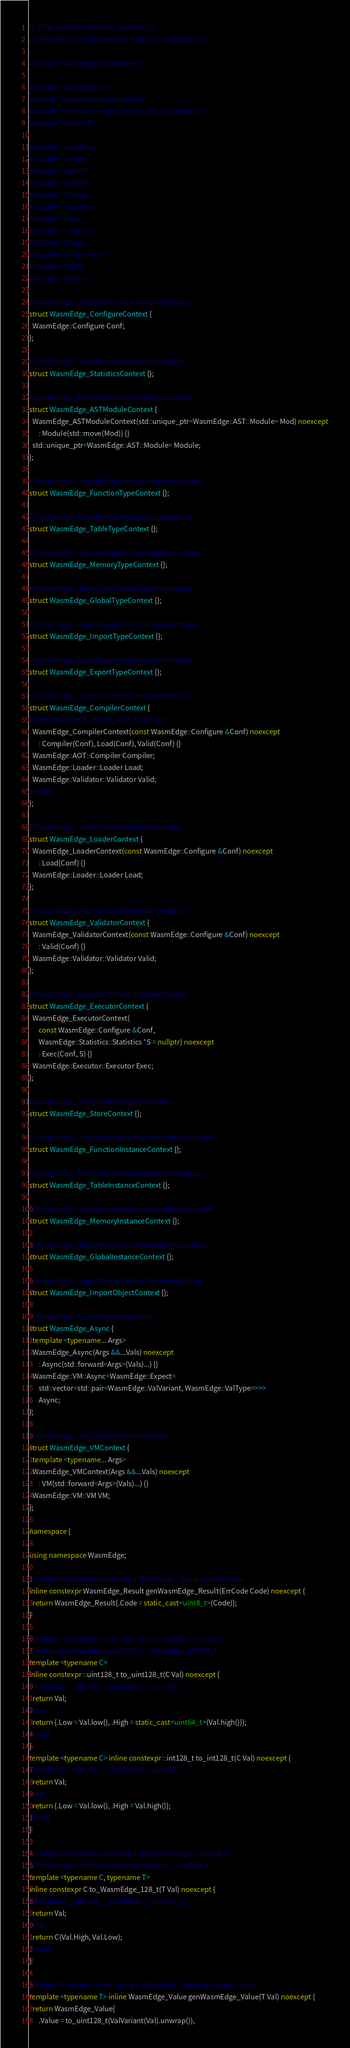Convert code to text. <code><loc_0><loc_0><loc_500><loc_500><_C++_>// SPDX-License-Identifier: Apache-2.0
// SPDX-FileCopyrightText: 2019-2022 Second State INC

#include "wasmedge/wasmedge.h"

#include "aot/compiler.h"
#include "host/wasi/wasimodule.h"
#include "host/wasmedge_process/processmodule.h"
#include "vm/vm.h"

#include <algorithm>
#include <chrono>
#include <cstdint>
#include <cstdlib>
#include <cstring>
#include <functional>
#include <map>
#include <memory>
#include <string>
#include <string_view>
#include <utility>
#include <vector>

// WasmEdge_ConfigureContext implementation.
struct WasmEdge_ConfigureContext {
  WasmEdge::Configure Conf;
};

// WasmEdge_StatisticsContext implementation.
struct WasmEdge_StatisticsContext {};

// WasmEdge_ASTModuleContext implementation.
struct WasmEdge_ASTModuleContext {
  WasmEdge_ASTModuleContext(std::unique_ptr<WasmEdge::AST::Module> Mod) noexcept
      : Module(std::move(Mod)) {}
  std::unique_ptr<WasmEdge::AST::Module> Module;
};

// WasmEdge_FunctionTypeContext implementation.
struct WasmEdge_FunctionTypeContext {};

// WasmEdge_TableTypeContext implementation.
struct WasmEdge_TableTypeContext {};

// WasmEdge_MemoryTypeContext implementation.
struct WasmEdge_MemoryTypeContext {};

// WasmEdge_GlobalTypeContext implementation.
struct WasmEdge_GlobalTypeContext {};

// WasmEdge_ImportTypeContext implementation.
struct WasmEdge_ImportTypeContext {};

// WasmEdge_ExportTypeContext implementation.
struct WasmEdge_ExportTypeContext {};

// WasmEdge_CompilerContext implementation.
struct WasmEdge_CompilerContext {
#ifdef WASMEDGE_BUILD_AOT_RUNTIME
  WasmEdge_CompilerContext(const WasmEdge::Configure &Conf) noexcept
      : Compiler(Conf), Load(Conf), Valid(Conf) {}
  WasmEdge::AOT::Compiler Compiler;
  WasmEdge::Loader::Loader Load;
  WasmEdge::Validator::Validator Valid;
#endif
};

// WasmEdge_LoaderContext implementation.
struct WasmEdge_LoaderContext {
  WasmEdge_LoaderContext(const WasmEdge::Configure &Conf) noexcept
      : Load(Conf) {}
  WasmEdge::Loader::Loader Load;
};

// WasmEdge_ValidatorContext implementation.
struct WasmEdge_ValidatorContext {
  WasmEdge_ValidatorContext(const WasmEdge::Configure &Conf) noexcept
      : Valid(Conf) {}
  WasmEdge::Validator::Validator Valid;
};

// WasmEdge_ExecutorContext implementation.
struct WasmEdge_ExecutorContext {
  WasmEdge_ExecutorContext(
      const WasmEdge::Configure &Conf,
      WasmEdge::Statistics::Statistics *S = nullptr) noexcept
      : Exec(Conf, S) {}
  WasmEdge::Executor::Executor Exec;
};

// WasmEdge_StoreContext implementation.
struct WasmEdge_StoreContext {};

// WasmEdge_FunctionInstanceContext implementation.
struct WasmEdge_FunctionInstanceContext {};

// WasmEdge_TableInstanceContext implementation.
struct WasmEdge_TableInstanceContext {};

// WasmEdge_MemoryInstanceContext implementation.
struct WasmEdge_MemoryInstanceContext {};

// WasmEdge_GlobalInstanceContext implementation.
struct WasmEdge_GlobalInstanceContext {};

// WasmEdge_ImportObjectContext implementation.
struct WasmEdge_ImportObjectContext {};

// WasmEdge_Async implementation.
struct WasmEdge_Async {
  template <typename... Args>
  WasmEdge_Async(Args &&...Vals) noexcept
      : Async(std::forward<Args>(Vals)...) {}
  WasmEdge::VM::Async<WasmEdge::Expect<
      std::vector<std::pair<WasmEdge::ValVariant, WasmEdge::ValType>>>>
      Async;
};

// WasmEdge_VMContext implementation.
struct WasmEdge_VMContext {
  template <typename... Args>
  WasmEdge_VMContext(Args &&...Vals) noexcept
      : VM(std::forward<Args>(Vals)...) {}
  WasmEdge::VM::VM VM;
};

namespace {

using namespace WasmEdge;

// Helper function for returning a WasmEdge_Result by error code.
inline constexpr WasmEdge_Result genWasmEdge_Result(ErrCode Code) noexcept {
  return WasmEdge_Result{.Code = static_cast<uint8_t>(Code)};
}

// Helper function for returning a struct uint128_t / int128_t
// from class WasmEdge::uint128_t / WasmEdge::int128_t.
template <typename C>
inline constexpr ::uint128_t to_uint128_t(C Val) noexcept {
#if defined(__x86_64__) || defined(__aarch64__)
  return Val;
#else
  return {.Low = Val.low(), .High = static_cast<uint64_t>(Val.high())};
#endif
}
template <typename C> inline constexpr ::int128_t to_int128_t(C Val) noexcept {
#if defined(__x86_64__) || defined(__aarch64__)
  return Val;
#else
  return {.Low = Val.low(), .High = Val.high()};
#endif
}

// Helper function for returning a class WasmEdge::uint128_t /
// WasmEdge::int128_t from struct uint128_t / int128_t.
template <typename C, typename T>
inline constexpr C to_WasmEdge_128_t(T Val) noexcept {
#if defined(__x86_64__) || defined(__aarch64__)
  return Val;
#else
  return C(Val.High, Val.Low);
#endif
}

// Helper functions for returning a WasmEdge_Value by various values.
template <typename T> inline WasmEdge_Value genWasmEdge_Value(T Val) noexcept {
  return WasmEdge_Value{
      .Value = to_uint128_t(ValVariant(Val).unwrap()),</code> 